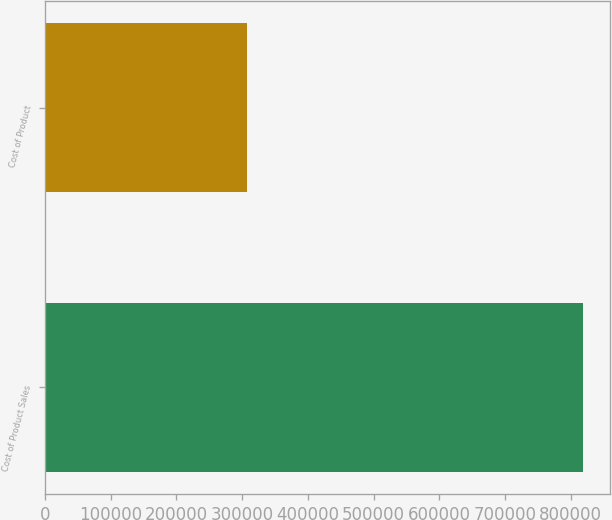Convert chart to OTSL. <chart><loc_0><loc_0><loc_500><loc_500><bar_chart><fcel>Cost of Product Sales<fcel>Cost of Product<nl><fcel>818160<fcel>307895<nl></chart> 